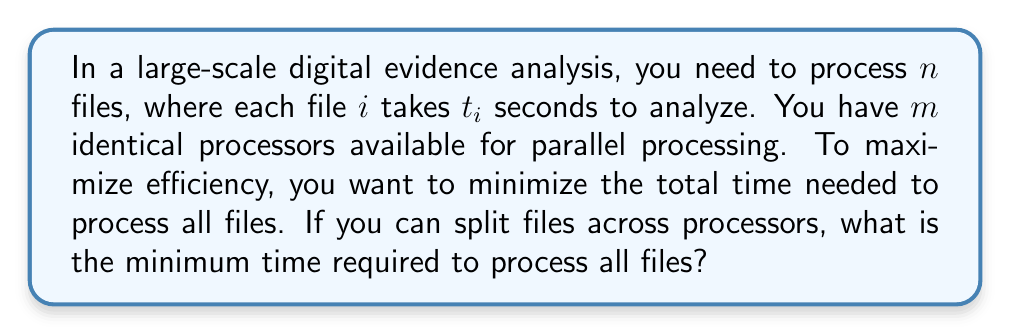Show me your answer to this math problem. To solve this optimization problem, we need to consider the following steps:

1) First, we need to understand that the optimal solution will distribute the workload as evenly as possible across all processors. This is because if one processor finishes before others, it could have been utilized to reduce the overall processing time.

2) The total processing time for all files is the sum of individual processing times:

   $$T_{total} = \sum_{i=1}^n t_i$$

3) If we had unlimited processors, we could process all files simultaneously, and the time would be the maximum of all individual processing times:

   $$T_{min} = \max_{i=1}^n t_i$$

4) However, we have $m$ processors. The optimal time will be somewhere between $T_{min}$ and $T_{total}$, depending on $m$.

5) The lower bound for the processing time is:

   $$T_{optimal} \geq \max\left(\frac{T_{total}}{m}, T_{min}\right)$$

6) This lower bound is actually achievable when we can split files across processors. We can schedule the tasks in a way that keeps all processors busy until the very end.

7) Therefore, the minimum time required to process all files is:

   $$T_{optimal} = \max\left(\frac{\sum_{i=1}^n t_i}{m}, \max_{i=1}^n t_i\right)$$

This solution ensures that we utilize all available processors efficiently, minimizing the total processing time for the large-scale digital evidence analysis.
Answer: $$T_{optimal} = \max\left(\frac{\sum_{i=1}^n t_i}{m}, \max_{i=1}^n t_i\right)$$ 